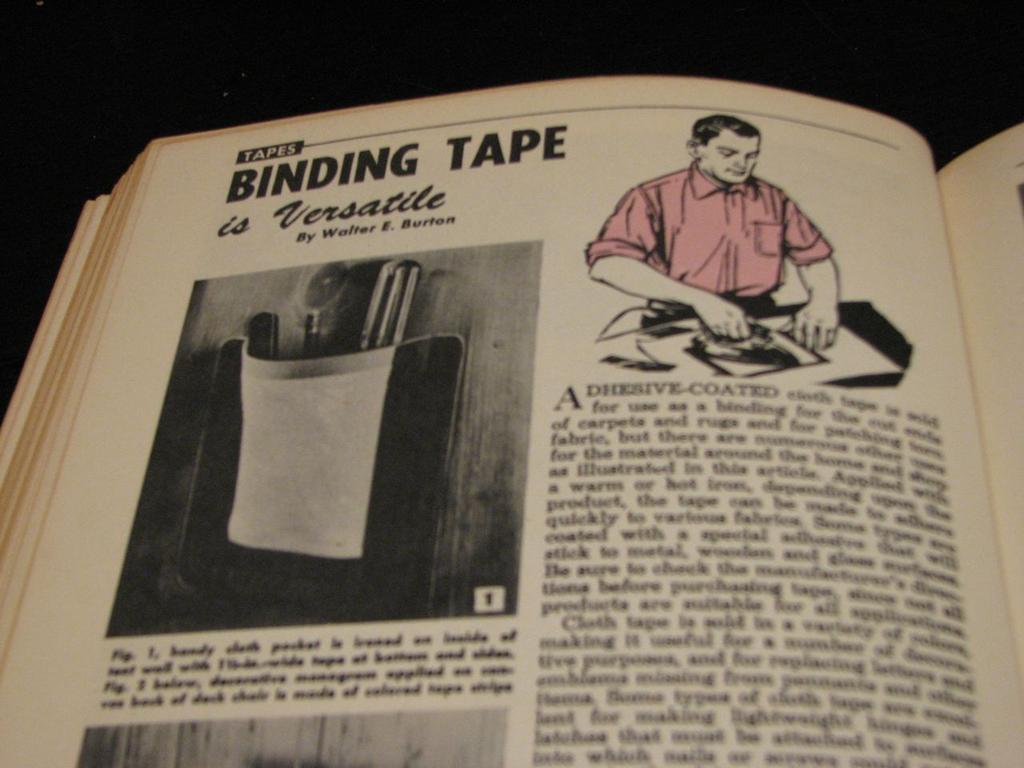What kind of tape is this page talking about?
Ensure brevity in your answer.  Binding. What is "binding" here?
Make the answer very short. Tape. 